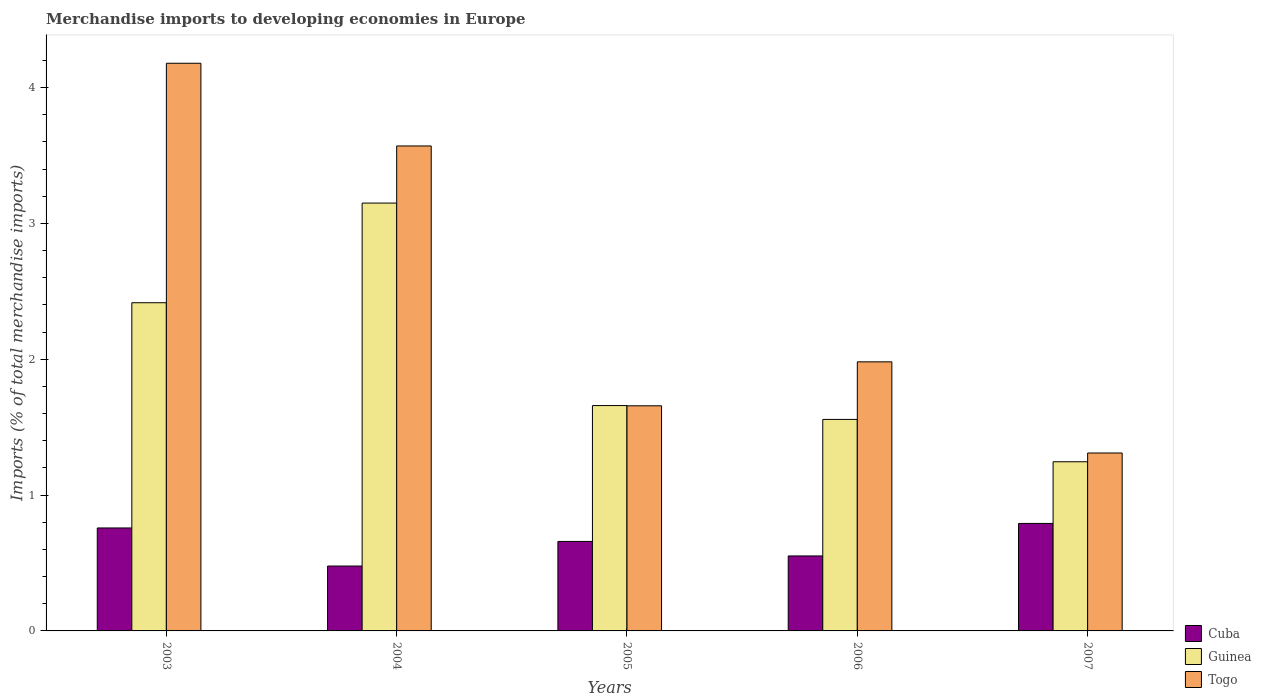Are the number of bars per tick equal to the number of legend labels?
Your answer should be very brief. Yes. How many bars are there on the 1st tick from the right?
Offer a very short reply. 3. What is the percentage total merchandise imports in Cuba in 2005?
Your response must be concise. 0.66. Across all years, what is the maximum percentage total merchandise imports in Cuba?
Provide a short and direct response. 0.79. Across all years, what is the minimum percentage total merchandise imports in Guinea?
Give a very brief answer. 1.25. In which year was the percentage total merchandise imports in Togo maximum?
Make the answer very short. 2003. In which year was the percentage total merchandise imports in Togo minimum?
Keep it short and to the point. 2007. What is the total percentage total merchandise imports in Guinea in the graph?
Provide a short and direct response. 10.03. What is the difference between the percentage total merchandise imports in Guinea in 2005 and that in 2007?
Offer a terse response. 0.41. What is the difference between the percentage total merchandise imports in Cuba in 2003 and the percentage total merchandise imports in Togo in 2006?
Provide a succinct answer. -1.22. What is the average percentage total merchandise imports in Guinea per year?
Provide a succinct answer. 2.01. In the year 2003, what is the difference between the percentage total merchandise imports in Cuba and percentage total merchandise imports in Guinea?
Provide a succinct answer. -1.66. What is the ratio of the percentage total merchandise imports in Cuba in 2004 to that in 2006?
Your answer should be compact. 0.87. Is the percentage total merchandise imports in Cuba in 2004 less than that in 2007?
Ensure brevity in your answer.  Yes. Is the difference between the percentage total merchandise imports in Cuba in 2003 and 2005 greater than the difference between the percentage total merchandise imports in Guinea in 2003 and 2005?
Offer a terse response. No. What is the difference between the highest and the second highest percentage total merchandise imports in Togo?
Offer a terse response. 0.61. What is the difference between the highest and the lowest percentage total merchandise imports in Togo?
Provide a short and direct response. 2.87. In how many years, is the percentage total merchandise imports in Togo greater than the average percentage total merchandise imports in Togo taken over all years?
Give a very brief answer. 2. Is the sum of the percentage total merchandise imports in Cuba in 2003 and 2005 greater than the maximum percentage total merchandise imports in Togo across all years?
Your answer should be very brief. No. What does the 3rd bar from the left in 2004 represents?
Make the answer very short. Togo. What does the 2nd bar from the right in 2003 represents?
Provide a succinct answer. Guinea. Is it the case that in every year, the sum of the percentage total merchandise imports in Cuba and percentage total merchandise imports in Guinea is greater than the percentage total merchandise imports in Togo?
Ensure brevity in your answer.  No. How many bars are there?
Provide a short and direct response. 15. How many years are there in the graph?
Ensure brevity in your answer.  5. What is the difference between two consecutive major ticks on the Y-axis?
Offer a terse response. 1. Are the values on the major ticks of Y-axis written in scientific E-notation?
Your answer should be compact. No. Does the graph contain any zero values?
Give a very brief answer. No. What is the title of the graph?
Your answer should be very brief. Merchandise imports to developing economies in Europe. Does "Ireland" appear as one of the legend labels in the graph?
Give a very brief answer. No. What is the label or title of the X-axis?
Your answer should be very brief. Years. What is the label or title of the Y-axis?
Keep it short and to the point. Imports (% of total merchandise imports). What is the Imports (% of total merchandise imports) of Cuba in 2003?
Your response must be concise. 0.76. What is the Imports (% of total merchandise imports) in Guinea in 2003?
Your response must be concise. 2.42. What is the Imports (% of total merchandise imports) of Togo in 2003?
Provide a short and direct response. 4.18. What is the Imports (% of total merchandise imports) of Cuba in 2004?
Offer a terse response. 0.48. What is the Imports (% of total merchandise imports) of Guinea in 2004?
Provide a succinct answer. 3.15. What is the Imports (% of total merchandise imports) in Togo in 2004?
Your response must be concise. 3.57. What is the Imports (% of total merchandise imports) of Cuba in 2005?
Your answer should be very brief. 0.66. What is the Imports (% of total merchandise imports) of Guinea in 2005?
Make the answer very short. 1.66. What is the Imports (% of total merchandise imports) in Togo in 2005?
Provide a succinct answer. 1.66. What is the Imports (% of total merchandise imports) in Cuba in 2006?
Your answer should be very brief. 0.55. What is the Imports (% of total merchandise imports) of Guinea in 2006?
Your response must be concise. 1.56. What is the Imports (% of total merchandise imports) in Togo in 2006?
Keep it short and to the point. 1.98. What is the Imports (% of total merchandise imports) of Cuba in 2007?
Offer a very short reply. 0.79. What is the Imports (% of total merchandise imports) of Guinea in 2007?
Ensure brevity in your answer.  1.25. What is the Imports (% of total merchandise imports) in Togo in 2007?
Your response must be concise. 1.31. Across all years, what is the maximum Imports (% of total merchandise imports) of Cuba?
Your response must be concise. 0.79. Across all years, what is the maximum Imports (% of total merchandise imports) of Guinea?
Your answer should be very brief. 3.15. Across all years, what is the maximum Imports (% of total merchandise imports) in Togo?
Offer a terse response. 4.18. Across all years, what is the minimum Imports (% of total merchandise imports) of Cuba?
Your answer should be very brief. 0.48. Across all years, what is the minimum Imports (% of total merchandise imports) of Guinea?
Make the answer very short. 1.25. Across all years, what is the minimum Imports (% of total merchandise imports) in Togo?
Your answer should be compact. 1.31. What is the total Imports (% of total merchandise imports) in Cuba in the graph?
Your answer should be compact. 3.24. What is the total Imports (% of total merchandise imports) in Guinea in the graph?
Ensure brevity in your answer.  10.03. What is the total Imports (% of total merchandise imports) of Togo in the graph?
Provide a short and direct response. 12.7. What is the difference between the Imports (% of total merchandise imports) in Cuba in 2003 and that in 2004?
Your answer should be compact. 0.28. What is the difference between the Imports (% of total merchandise imports) of Guinea in 2003 and that in 2004?
Your answer should be very brief. -0.73. What is the difference between the Imports (% of total merchandise imports) of Togo in 2003 and that in 2004?
Offer a very short reply. 0.61. What is the difference between the Imports (% of total merchandise imports) of Cuba in 2003 and that in 2005?
Your answer should be very brief. 0.1. What is the difference between the Imports (% of total merchandise imports) of Guinea in 2003 and that in 2005?
Make the answer very short. 0.76. What is the difference between the Imports (% of total merchandise imports) in Togo in 2003 and that in 2005?
Make the answer very short. 2.52. What is the difference between the Imports (% of total merchandise imports) in Cuba in 2003 and that in 2006?
Ensure brevity in your answer.  0.21. What is the difference between the Imports (% of total merchandise imports) in Guinea in 2003 and that in 2006?
Give a very brief answer. 0.86. What is the difference between the Imports (% of total merchandise imports) of Togo in 2003 and that in 2006?
Make the answer very short. 2.2. What is the difference between the Imports (% of total merchandise imports) of Cuba in 2003 and that in 2007?
Offer a terse response. -0.03. What is the difference between the Imports (% of total merchandise imports) in Guinea in 2003 and that in 2007?
Give a very brief answer. 1.17. What is the difference between the Imports (% of total merchandise imports) of Togo in 2003 and that in 2007?
Ensure brevity in your answer.  2.87. What is the difference between the Imports (% of total merchandise imports) in Cuba in 2004 and that in 2005?
Ensure brevity in your answer.  -0.18. What is the difference between the Imports (% of total merchandise imports) of Guinea in 2004 and that in 2005?
Keep it short and to the point. 1.49. What is the difference between the Imports (% of total merchandise imports) of Togo in 2004 and that in 2005?
Offer a very short reply. 1.91. What is the difference between the Imports (% of total merchandise imports) of Cuba in 2004 and that in 2006?
Give a very brief answer. -0.07. What is the difference between the Imports (% of total merchandise imports) of Guinea in 2004 and that in 2006?
Give a very brief answer. 1.59. What is the difference between the Imports (% of total merchandise imports) of Togo in 2004 and that in 2006?
Keep it short and to the point. 1.59. What is the difference between the Imports (% of total merchandise imports) of Cuba in 2004 and that in 2007?
Your answer should be very brief. -0.31. What is the difference between the Imports (% of total merchandise imports) in Guinea in 2004 and that in 2007?
Ensure brevity in your answer.  1.9. What is the difference between the Imports (% of total merchandise imports) of Togo in 2004 and that in 2007?
Ensure brevity in your answer.  2.26. What is the difference between the Imports (% of total merchandise imports) of Cuba in 2005 and that in 2006?
Provide a succinct answer. 0.11. What is the difference between the Imports (% of total merchandise imports) of Guinea in 2005 and that in 2006?
Make the answer very short. 0.1. What is the difference between the Imports (% of total merchandise imports) in Togo in 2005 and that in 2006?
Make the answer very short. -0.32. What is the difference between the Imports (% of total merchandise imports) of Cuba in 2005 and that in 2007?
Your answer should be very brief. -0.13. What is the difference between the Imports (% of total merchandise imports) of Guinea in 2005 and that in 2007?
Provide a succinct answer. 0.41. What is the difference between the Imports (% of total merchandise imports) in Togo in 2005 and that in 2007?
Offer a terse response. 0.35. What is the difference between the Imports (% of total merchandise imports) in Cuba in 2006 and that in 2007?
Provide a short and direct response. -0.24. What is the difference between the Imports (% of total merchandise imports) in Guinea in 2006 and that in 2007?
Your response must be concise. 0.31. What is the difference between the Imports (% of total merchandise imports) in Togo in 2006 and that in 2007?
Keep it short and to the point. 0.67. What is the difference between the Imports (% of total merchandise imports) of Cuba in 2003 and the Imports (% of total merchandise imports) of Guinea in 2004?
Your answer should be compact. -2.39. What is the difference between the Imports (% of total merchandise imports) of Cuba in 2003 and the Imports (% of total merchandise imports) of Togo in 2004?
Offer a very short reply. -2.81. What is the difference between the Imports (% of total merchandise imports) in Guinea in 2003 and the Imports (% of total merchandise imports) in Togo in 2004?
Ensure brevity in your answer.  -1.15. What is the difference between the Imports (% of total merchandise imports) in Cuba in 2003 and the Imports (% of total merchandise imports) in Guinea in 2005?
Ensure brevity in your answer.  -0.9. What is the difference between the Imports (% of total merchandise imports) in Cuba in 2003 and the Imports (% of total merchandise imports) in Togo in 2005?
Make the answer very short. -0.9. What is the difference between the Imports (% of total merchandise imports) in Guinea in 2003 and the Imports (% of total merchandise imports) in Togo in 2005?
Provide a succinct answer. 0.76. What is the difference between the Imports (% of total merchandise imports) of Cuba in 2003 and the Imports (% of total merchandise imports) of Guinea in 2006?
Your answer should be compact. -0.8. What is the difference between the Imports (% of total merchandise imports) in Cuba in 2003 and the Imports (% of total merchandise imports) in Togo in 2006?
Keep it short and to the point. -1.22. What is the difference between the Imports (% of total merchandise imports) of Guinea in 2003 and the Imports (% of total merchandise imports) of Togo in 2006?
Your response must be concise. 0.44. What is the difference between the Imports (% of total merchandise imports) in Cuba in 2003 and the Imports (% of total merchandise imports) in Guinea in 2007?
Give a very brief answer. -0.49. What is the difference between the Imports (% of total merchandise imports) in Cuba in 2003 and the Imports (% of total merchandise imports) in Togo in 2007?
Your answer should be compact. -0.55. What is the difference between the Imports (% of total merchandise imports) of Guinea in 2003 and the Imports (% of total merchandise imports) of Togo in 2007?
Offer a very short reply. 1.11. What is the difference between the Imports (% of total merchandise imports) in Cuba in 2004 and the Imports (% of total merchandise imports) in Guinea in 2005?
Your answer should be compact. -1.18. What is the difference between the Imports (% of total merchandise imports) of Cuba in 2004 and the Imports (% of total merchandise imports) of Togo in 2005?
Ensure brevity in your answer.  -1.18. What is the difference between the Imports (% of total merchandise imports) of Guinea in 2004 and the Imports (% of total merchandise imports) of Togo in 2005?
Ensure brevity in your answer.  1.49. What is the difference between the Imports (% of total merchandise imports) in Cuba in 2004 and the Imports (% of total merchandise imports) in Guinea in 2006?
Offer a very short reply. -1.08. What is the difference between the Imports (% of total merchandise imports) of Cuba in 2004 and the Imports (% of total merchandise imports) of Togo in 2006?
Make the answer very short. -1.5. What is the difference between the Imports (% of total merchandise imports) of Guinea in 2004 and the Imports (% of total merchandise imports) of Togo in 2006?
Your response must be concise. 1.17. What is the difference between the Imports (% of total merchandise imports) in Cuba in 2004 and the Imports (% of total merchandise imports) in Guinea in 2007?
Your answer should be very brief. -0.77. What is the difference between the Imports (% of total merchandise imports) in Cuba in 2004 and the Imports (% of total merchandise imports) in Togo in 2007?
Give a very brief answer. -0.83. What is the difference between the Imports (% of total merchandise imports) of Guinea in 2004 and the Imports (% of total merchandise imports) of Togo in 2007?
Offer a very short reply. 1.84. What is the difference between the Imports (% of total merchandise imports) in Cuba in 2005 and the Imports (% of total merchandise imports) in Guinea in 2006?
Your answer should be very brief. -0.9. What is the difference between the Imports (% of total merchandise imports) in Cuba in 2005 and the Imports (% of total merchandise imports) in Togo in 2006?
Offer a terse response. -1.32. What is the difference between the Imports (% of total merchandise imports) of Guinea in 2005 and the Imports (% of total merchandise imports) of Togo in 2006?
Provide a succinct answer. -0.32. What is the difference between the Imports (% of total merchandise imports) of Cuba in 2005 and the Imports (% of total merchandise imports) of Guinea in 2007?
Offer a terse response. -0.59. What is the difference between the Imports (% of total merchandise imports) of Cuba in 2005 and the Imports (% of total merchandise imports) of Togo in 2007?
Offer a very short reply. -0.65. What is the difference between the Imports (% of total merchandise imports) of Guinea in 2005 and the Imports (% of total merchandise imports) of Togo in 2007?
Keep it short and to the point. 0.35. What is the difference between the Imports (% of total merchandise imports) of Cuba in 2006 and the Imports (% of total merchandise imports) of Guinea in 2007?
Keep it short and to the point. -0.69. What is the difference between the Imports (% of total merchandise imports) in Cuba in 2006 and the Imports (% of total merchandise imports) in Togo in 2007?
Provide a short and direct response. -0.76. What is the difference between the Imports (% of total merchandise imports) of Guinea in 2006 and the Imports (% of total merchandise imports) of Togo in 2007?
Make the answer very short. 0.25. What is the average Imports (% of total merchandise imports) in Cuba per year?
Your answer should be compact. 0.65. What is the average Imports (% of total merchandise imports) in Guinea per year?
Provide a succinct answer. 2.01. What is the average Imports (% of total merchandise imports) in Togo per year?
Give a very brief answer. 2.54. In the year 2003, what is the difference between the Imports (% of total merchandise imports) in Cuba and Imports (% of total merchandise imports) in Guinea?
Your answer should be compact. -1.66. In the year 2003, what is the difference between the Imports (% of total merchandise imports) of Cuba and Imports (% of total merchandise imports) of Togo?
Provide a short and direct response. -3.42. In the year 2003, what is the difference between the Imports (% of total merchandise imports) in Guinea and Imports (% of total merchandise imports) in Togo?
Your answer should be compact. -1.76. In the year 2004, what is the difference between the Imports (% of total merchandise imports) of Cuba and Imports (% of total merchandise imports) of Guinea?
Provide a succinct answer. -2.67. In the year 2004, what is the difference between the Imports (% of total merchandise imports) in Cuba and Imports (% of total merchandise imports) in Togo?
Your answer should be very brief. -3.09. In the year 2004, what is the difference between the Imports (% of total merchandise imports) of Guinea and Imports (% of total merchandise imports) of Togo?
Offer a very short reply. -0.42. In the year 2005, what is the difference between the Imports (% of total merchandise imports) in Cuba and Imports (% of total merchandise imports) in Guinea?
Give a very brief answer. -1. In the year 2005, what is the difference between the Imports (% of total merchandise imports) in Cuba and Imports (% of total merchandise imports) in Togo?
Ensure brevity in your answer.  -1. In the year 2005, what is the difference between the Imports (% of total merchandise imports) of Guinea and Imports (% of total merchandise imports) of Togo?
Provide a short and direct response. 0. In the year 2006, what is the difference between the Imports (% of total merchandise imports) in Cuba and Imports (% of total merchandise imports) in Guinea?
Keep it short and to the point. -1. In the year 2006, what is the difference between the Imports (% of total merchandise imports) in Cuba and Imports (% of total merchandise imports) in Togo?
Provide a short and direct response. -1.43. In the year 2006, what is the difference between the Imports (% of total merchandise imports) of Guinea and Imports (% of total merchandise imports) of Togo?
Your answer should be very brief. -0.42. In the year 2007, what is the difference between the Imports (% of total merchandise imports) of Cuba and Imports (% of total merchandise imports) of Guinea?
Provide a short and direct response. -0.45. In the year 2007, what is the difference between the Imports (% of total merchandise imports) of Cuba and Imports (% of total merchandise imports) of Togo?
Give a very brief answer. -0.52. In the year 2007, what is the difference between the Imports (% of total merchandise imports) in Guinea and Imports (% of total merchandise imports) in Togo?
Provide a short and direct response. -0.06. What is the ratio of the Imports (% of total merchandise imports) in Cuba in 2003 to that in 2004?
Provide a short and direct response. 1.59. What is the ratio of the Imports (% of total merchandise imports) in Guinea in 2003 to that in 2004?
Offer a terse response. 0.77. What is the ratio of the Imports (% of total merchandise imports) in Togo in 2003 to that in 2004?
Offer a terse response. 1.17. What is the ratio of the Imports (% of total merchandise imports) of Cuba in 2003 to that in 2005?
Keep it short and to the point. 1.15. What is the ratio of the Imports (% of total merchandise imports) of Guinea in 2003 to that in 2005?
Give a very brief answer. 1.46. What is the ratio of the Imports (% of total merchandise imports) in Togo in 2003 to that in 2005?
Offer a terse response. 2.52. What is the ratio of the Imports (% of total merchandise imports) of Cuba in 2003 to that in 2006?
Offer a terse response. 1.37. What is the ratio of the Imports (% of total merchandise imports) in Guinea in 2003 to that in 2006?
Ensure brevity in your answer.  1.55. What is the ratio of the Imports (% of total merchandise imports) of Togo in 2003 to that in 2006?
Ensure brevity in your answer.  2.11. What is the ratio of the Imports (% of total merchandise imports) in Cuba in 2003 to that in 2007?
Your answer should be very brief. 0.96. What is the ratio of the Imports (% of total merchandise imports) in Guinea in 2003 to that in 2007?
Your response must be concise. 1.94. What is the ratio of the Imports (% of total merchandise imports) of Togo in 2003 to that in 2007?
Provide a short and direct response. 3.19. What is the ratio of the Imports (% of total merchandise imports) of Cuba in 2004 to that in 2005?
Give a very brief answer. 0.73. What is the ratio of the Imports (% of total merchandise imports) of Guinea in 2004 to that in 2005?
Your response must be concise. 1.9. What is the ratio of the Imports (% of total merchandise imports) in Togo in 2004 to that in 2005?
Keep it short and to the point. 2.15. What is the ratio of the Imports (% of total merchandise imports) of Cuba in 2004 to that in 2006?
Offer a very short reply. 0.87. What is the ratio of the Imports (% of total merchandise imports) of Guinea in 2004 to that in 2006?
Offer a very short reply. 2.02. What is the ratio of the Imports (% of total merchandise imports) in Togo in 2004 to that in 2006?
Your answer should be compact. 1.8. What is the ratio of the Imports (% of total merchandise imports) in Cuba in 2004 to that in 2007?
Keep it short and to the point. 0.6. What is the ratio of the Imports (% of total merchandise imports) of Guinea in 2004 to that in 2007?
Offer a very short reply. 2.53. What is the ratio of the Imports (% of total merchandise imports) in Togo in 2004 to that in 2007?
Offer a terse response. 2.73. What is the ratio of the Imports (% of total merchandise imports) of Cuba in 2005 to that in 2006?
Your response must be concise. 1.19. What is the ratio of the Imports (% of total merchandise imports) of Guinea in 2005 to that in 2006?
Provide a short and direct response. 1.07. What is the ratio of the Imports (% of total merchandise imports) in Togo in 2005 to that in 2006?
Offer a very short reply. 0.84. What is the ratio of the Imports (% of total merchandise imports) in Cuba in 2005 to that in 2007?
Your answer should be very brief. 0.83. What is the ratio of the Imports (% of total merchandise imports) in Guinea in 2005 to that in 2007?
Make the answer very short. 1.33. What is the ratio of the Imports (% of total merchandise imports) in Togo in 2005 to that in 2007?
Keep it short and to the point. 1.27. What is the ratio of the Imports (% of total merchandise imports) in Cuba in 2006 to that in 2007?
Your response must be concise. 0.7. What is the ratio of the Imports (% of total merchandise imports) in Guinea in 2006 to that in 2007?
Ensure brevity in your answer.  1.25. What is the ratio of the Imports (% of total merchandise imports) of Togo in 2006 to that in 2007?
Make the answer very short. 1.51. What is the difference between the highest and the second highest Imports (% of total merchandise imports) in Cuba?
Your response must be concise. 0.03. What is the difference between the highest and the second highest Imports (% of total merchandise imports) of Guinea?
Provide a succinct answer. 0.73. What is the difference between the highest and the second highest Imports (% of total merchandise imports) in Togo?
Your response must be concise. 0.61. What is the difference between the highest and the lowest Imports (% of total merchandise imports) in Cuba?
Your answer should be very brief. 0.31. What is the difference between the highest and the lowest Imports (% of total merchandise imports) in Guinea?
Ensure brevity in your answer.  1.9. What is the difference between the highest and the lowest Imports (% of total merchandise imports) in Togo?
Your response must be concise. 2.87. 